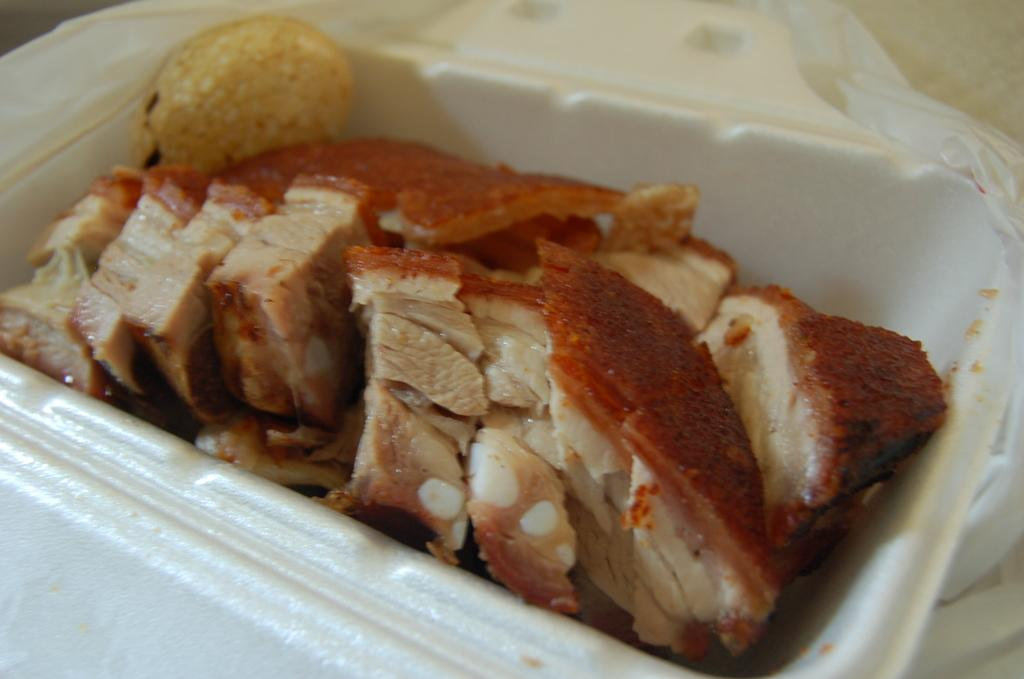What type of food can be seen in the image? There are meat pieces in the image. What is the color of the bowl containing the food item? The food item is in a white-colored bowl in the image. What is the color of the background in the image? The background of the image is white in color. What event is being represented in the image? The image does not depict any specific event; it simply shows meat pieces in a white bowl against a white background. 